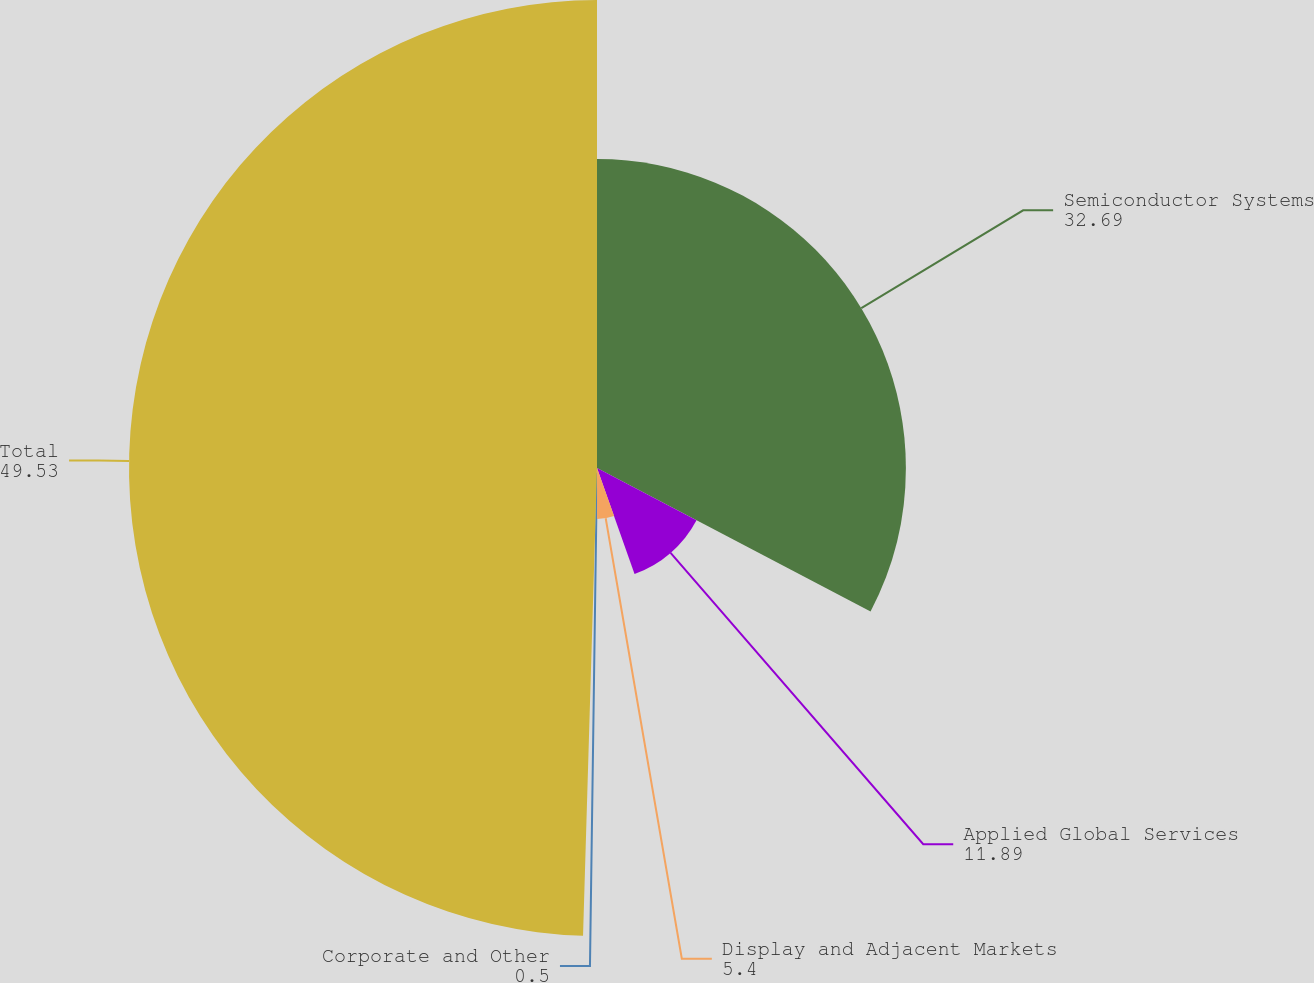<chart> <loc_0><loc_0><loc_500><loc_500><pie_chart><fcel>Semiconductor Systems<fcel>Applied Global Services<fcel>Display and Adjacent Markets<fcel>Corporate and Other<fcel>Total<nl><fcel>32.69%<fcel>11.89%<fcel>5.4%<fcel>0.5%<fcel>49.53%<nl></chart> 